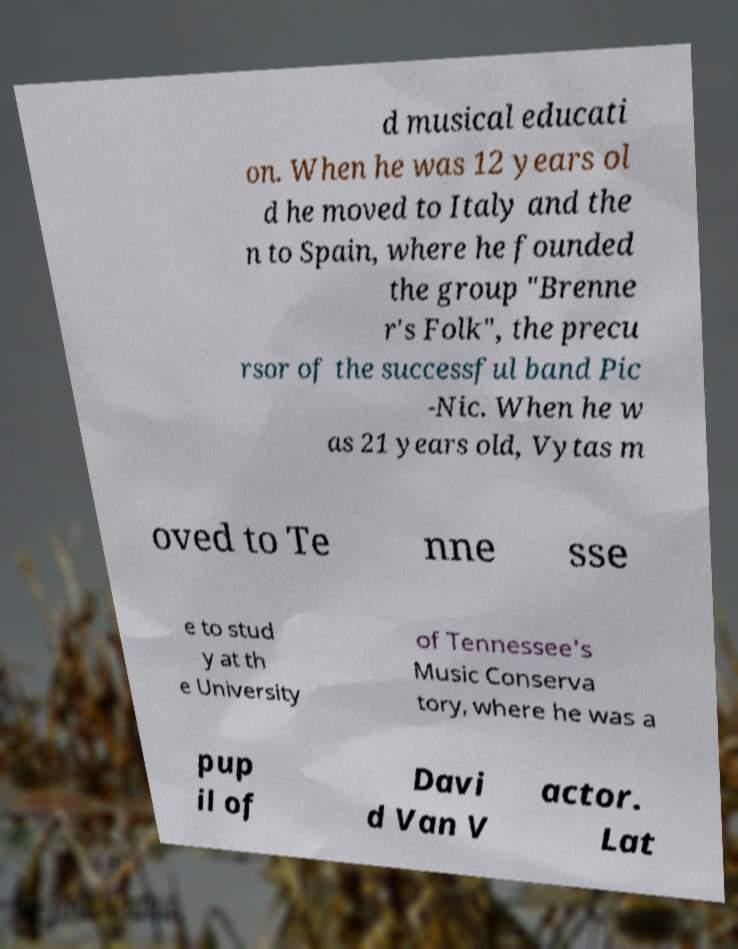Can you read and provide the text displayed in the image?This photo seems to have some interesting text. Can you extract and type it out for me? d musical educati on. When he was 12 years ol d he moved to Italy and the n to Spain, where he founded the group "Brenne r's Folk", the precu rsor of the successful band Pic -Nic. When he w as 21 years old, Vytas m oved to Te nne sse e to stud y at th e University of Tennessee's Music Conserva tory, where he was a pup il of Davi d Van V actor. Lat 